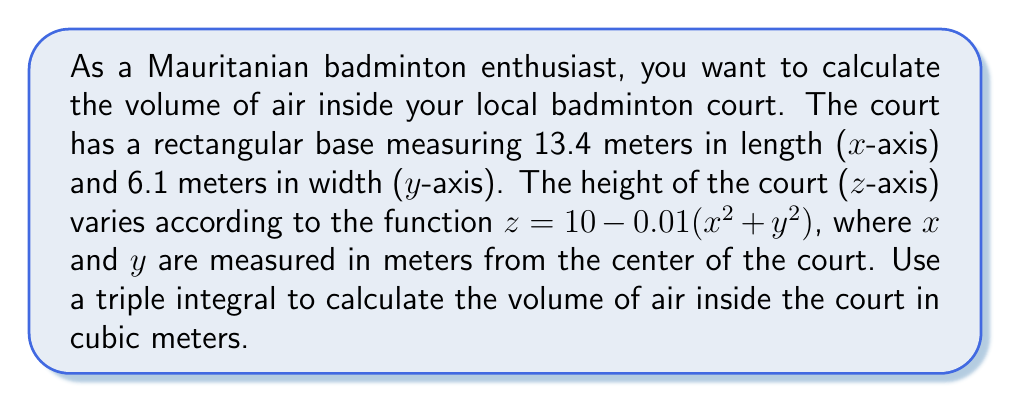Show me your answer to this math problem. To calculate the volume using a triple integral, we need to integrate over the x, y, and z dimensions:

1) Set up the triple integral:
   $$V = \int\int\int_R dV = \int_{-6.7}^{6.7} \int_{-3.05}^{3.05} \int_0^{10-0.01(x^2+y^2)} dz dy dx$$

2) Integrate with respect to z:
   $$V = \int_{-6.7}^{6.7} \int_{-3.05}^{3.05} [z]_0^{10-0.01(x^2+y^2)} dy dx$$
   $$V = \int_{-6.7}^{6.7} \int_{-3.05}^{3.05} (10-0.01(x^2+y^2)) dy dx$$

3) Integrate with respect to y:
   $$V = \int_{-6.7}^{6.7} [10y - 0.01x^2y - \frac{0.01}{3}y^3]_{-3.05}^{3.05} dx$$
   $$V = \int_{-6.7}^{6.7} (61 - 0.061x^2 - 0.62) dx$$
   $$V = \int_{-6.7}^{6.7} (60.38 - 0.061x^2) dx$$

4) Integrate with respect to x:
   $$V = [60.38x - \frac{0.061}{3}x^3]_{-6.7}^{6.7}$$
   $$V = (404.546 - 1.9184) - (-404.546 - 1.9184)$$
   $$V = 808.1552 + 3.8368$$
   $$V = 811.992 \text{ m}^3$$

Therefore, the volume of air inside the badminton court is approximately 811.992 cubic meters.
Answer: $811.992 \text{ m}^3$ 